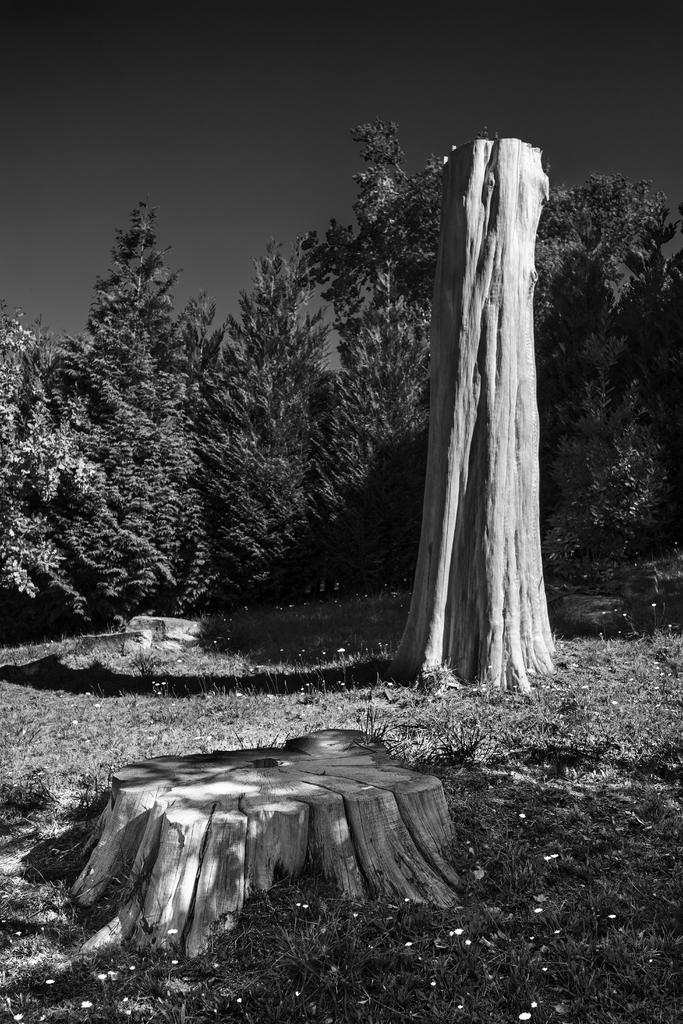What type of vegetation can be seen in the image? There are tree trunks and grass in the image. What else can be observed in the image? There are shadows in the image. How many trees are visible in the image? There are multiple trees in the image. What is the color scheme of the image? The image is black and white in color. Can you hear the corn rustling in the image? There is no corn present in the image, so it cannot be heard rustling. 